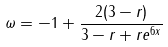<formula> <loc_0><loc_0><loc_500><loc_500>\omega = - 1 + \frac { 2 ( 3 - r ) } { 3 - r + r e ^ { 6 x } }</formula> 